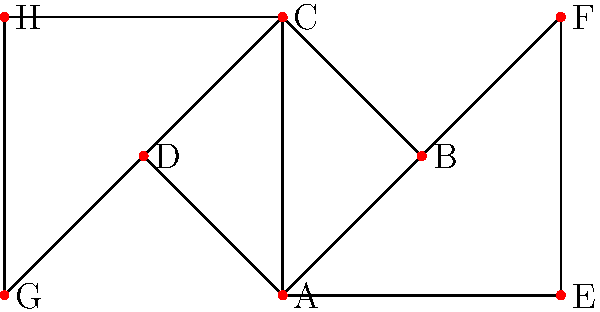In the given trade network visualization, which city has the highest degree centrality? To determine the city with the highest degree centrality, we need to follow these steps:

1. Understand degree centrality: It is a measure of the number of direct connections a node has in a network.

2. Count the connections for each city:
   A: 4 connections (B, C, D, E)
   B: 3 connections (A, C, F)
   C: 4 connections (A, B, D, H)
   D: 3 connections (A, C, G)
   E: 2 connections (A, F)
   F: 2 connections (B, E)
   G: 2 connections (D, H)
   H: 2 connections (C, G)

3. Identify the highest count: The maximum number of connections is 4.

4. Find the city(ies) with the highest count: Both A and C have 4 connections.

5. In case of a tie, we consider both cities as having the highest degree centrality. However, for this question, we'll choose the first one alphabetically.

Therefore, city A has the highest degree centrality in this trade network visualization.
Answer: A 